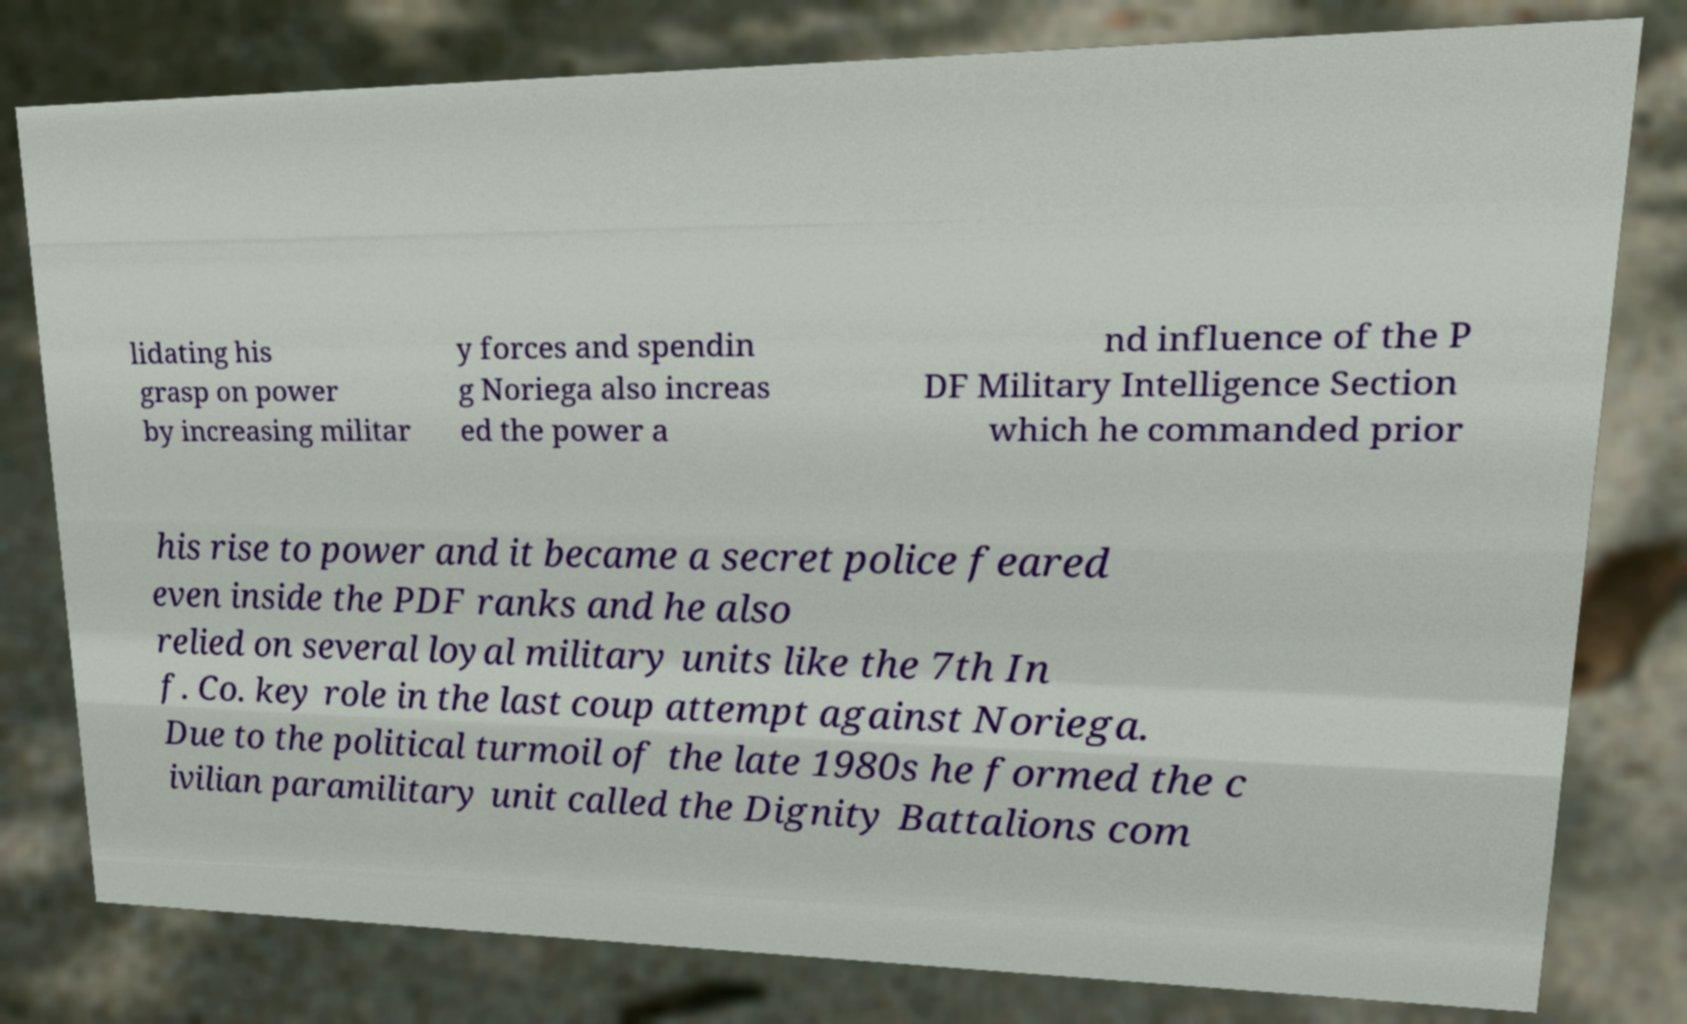Could you assist in decoding the text presented in this image and type it out clearly? lidating his grasp on power by increasing militar y forces and spendin g Noriega also increas ed the power a nd influence of the P DF Military Intelligence Section which he commanded prior his rise to power and it became a secret police feared even inside the PDF ranks and he also relied on several loyal military units like the 7th In f. Co. key role in the last coup attempt against Noriega. Due to the political turmoil of the late 1980s he formed the c ivilian paramilitary unit called the Dignity Battalions com 